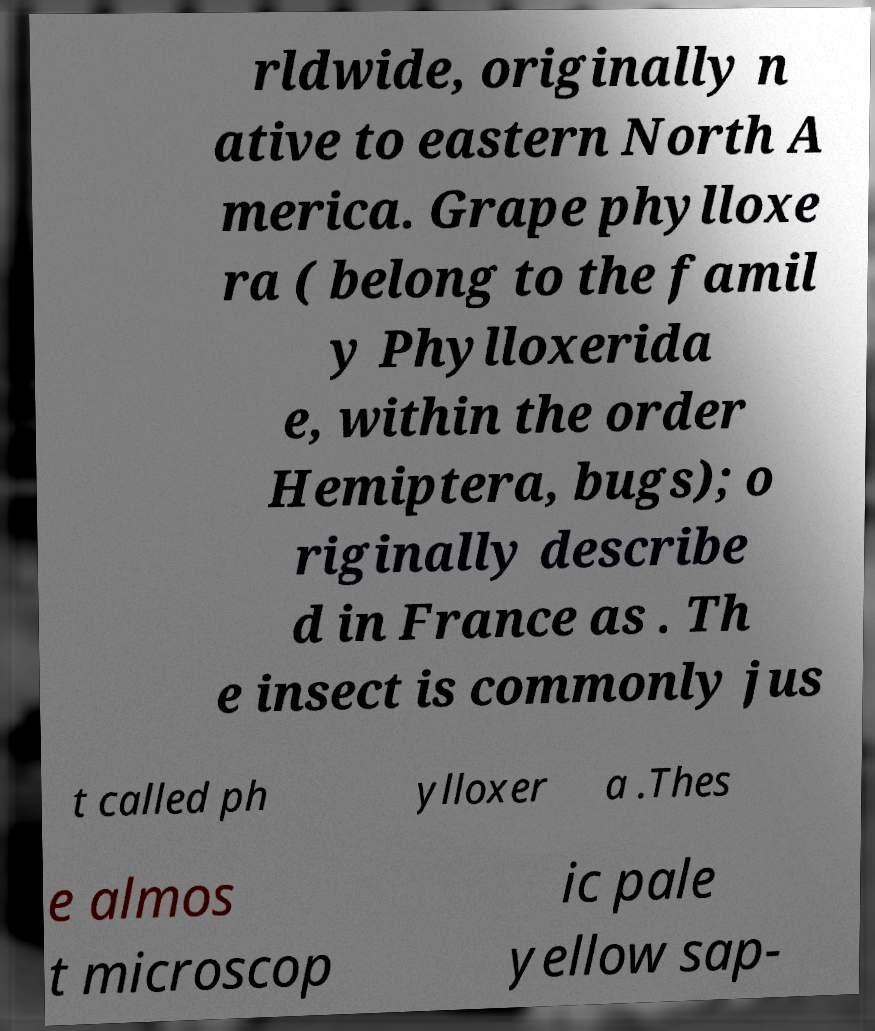Can you accurately transcribe the text from the provided image for me? rldwide, originally n ative to eastern North A merica. Grape phylloxe ra ( belong to the famil y Phylloxerida e, within the order Hemiptera, bugs); o riginally describe d in France as . Th e insect is commonly jus t called ph ylloxer a .Thes e almos t microscop ic pale yellow sap- 